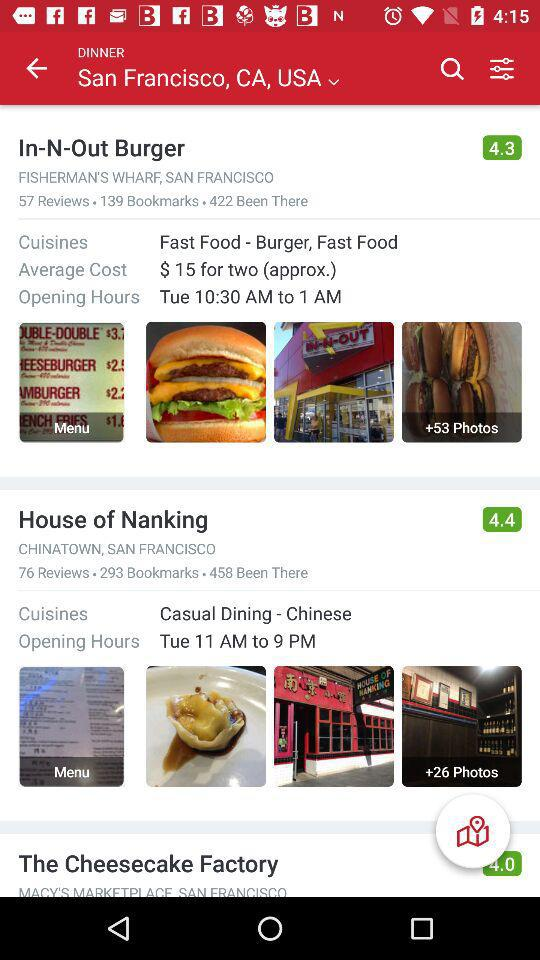Which location is selected? The selected location is San Francisco, CA, USA. 